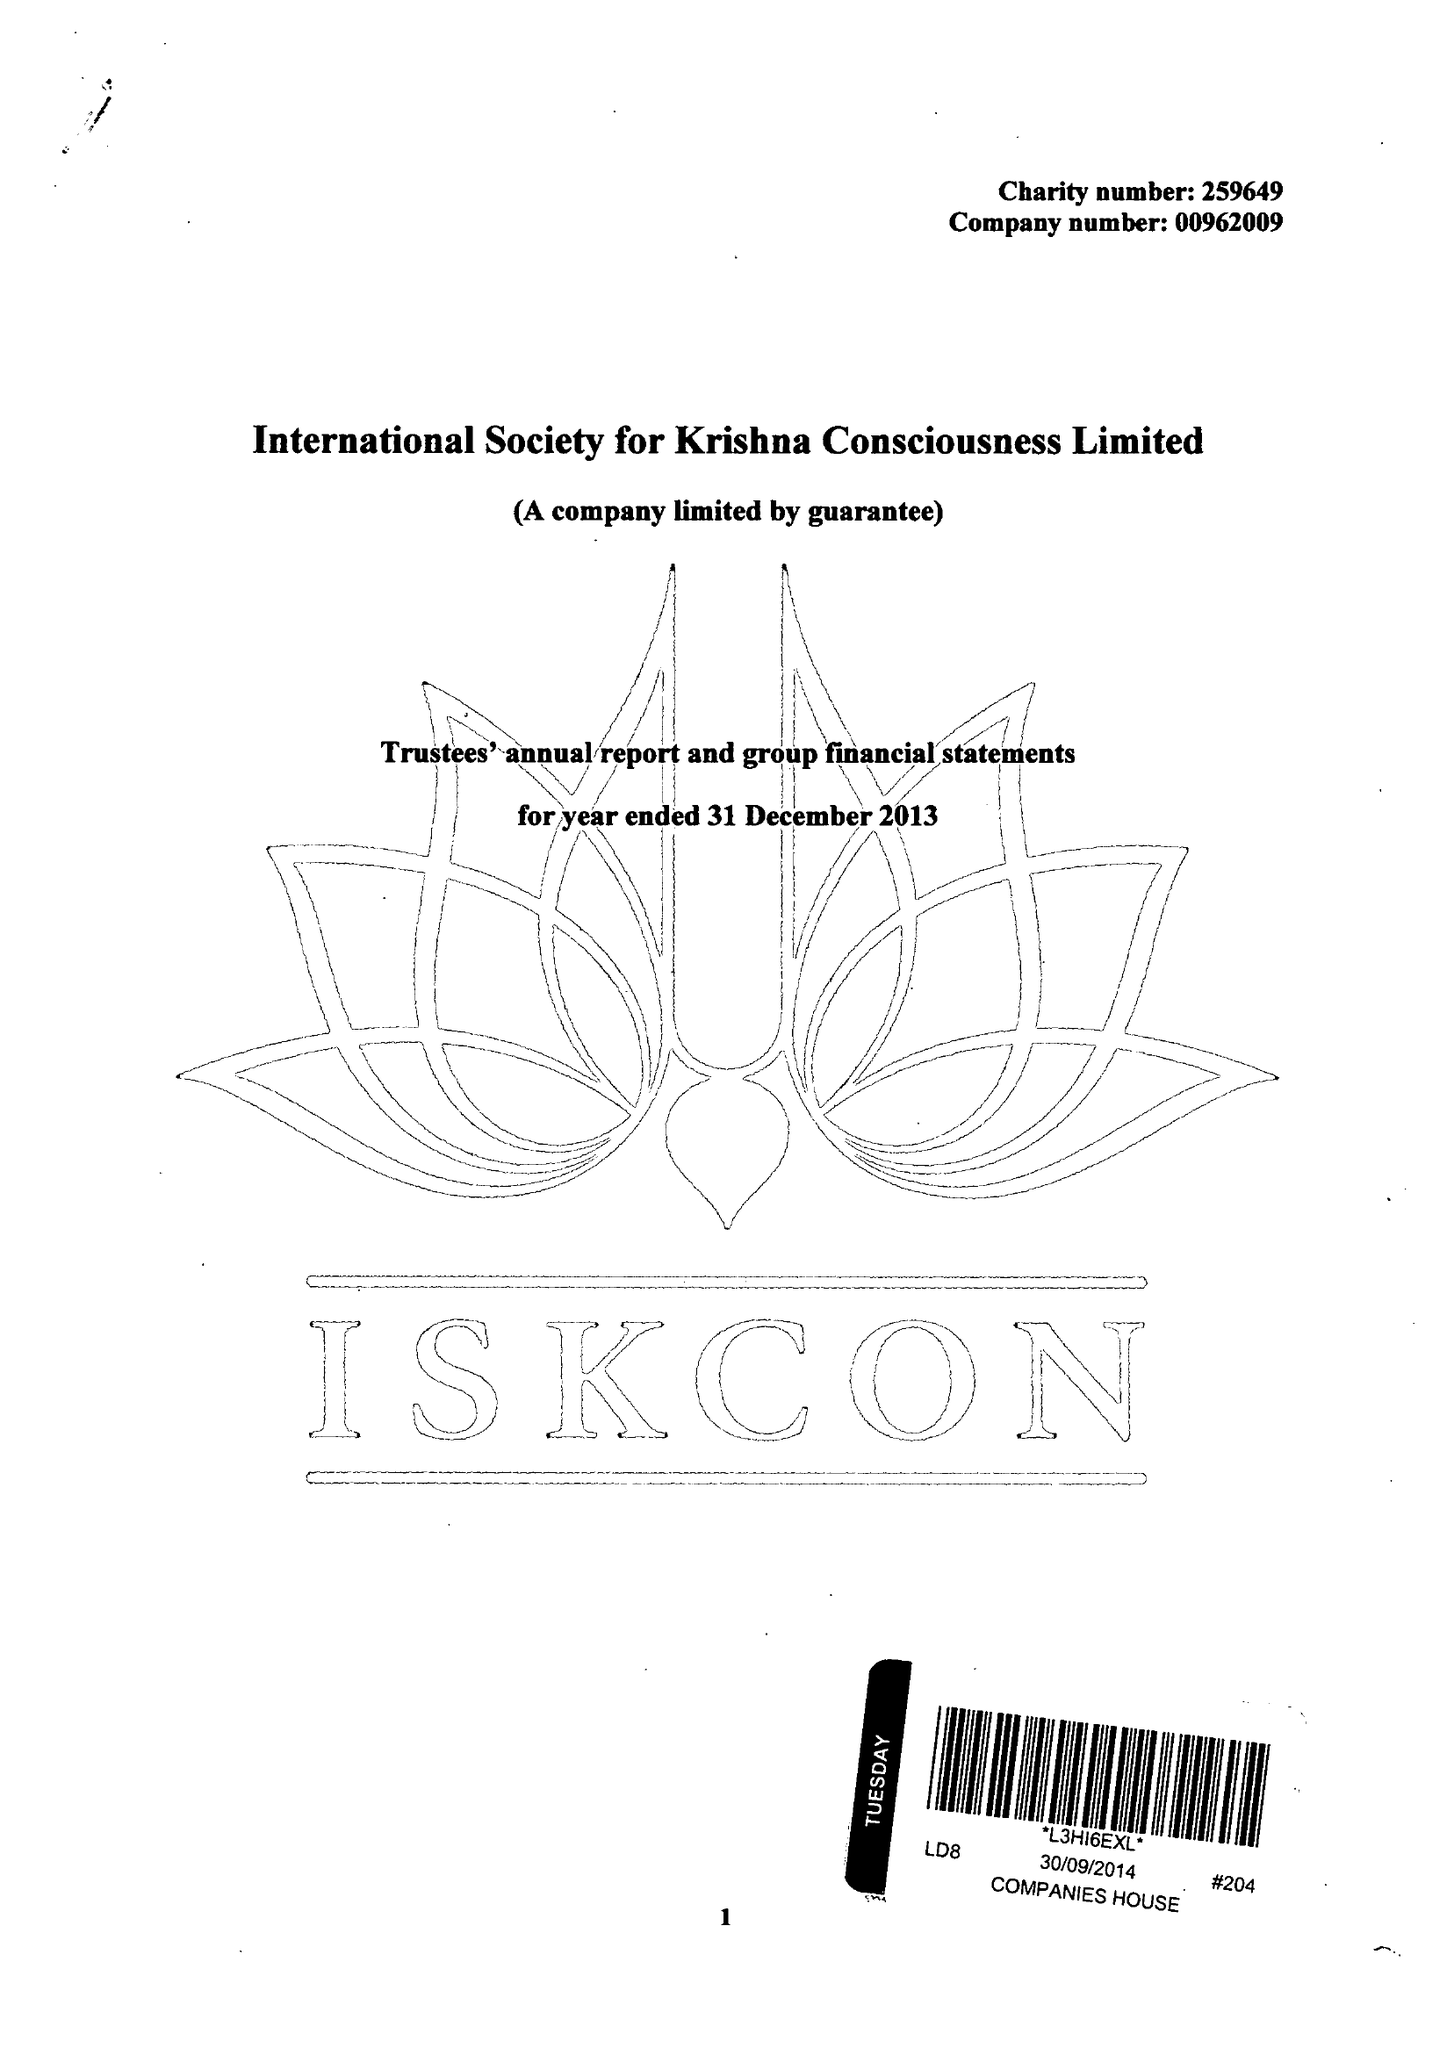What is the value for the address__postcode?
Answer the question using a single word or phrase. WD7 8LA 